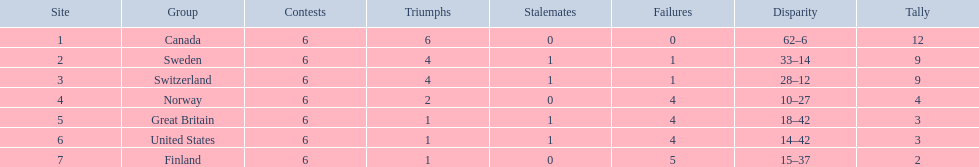Which country conceded the least goals? Finland. 